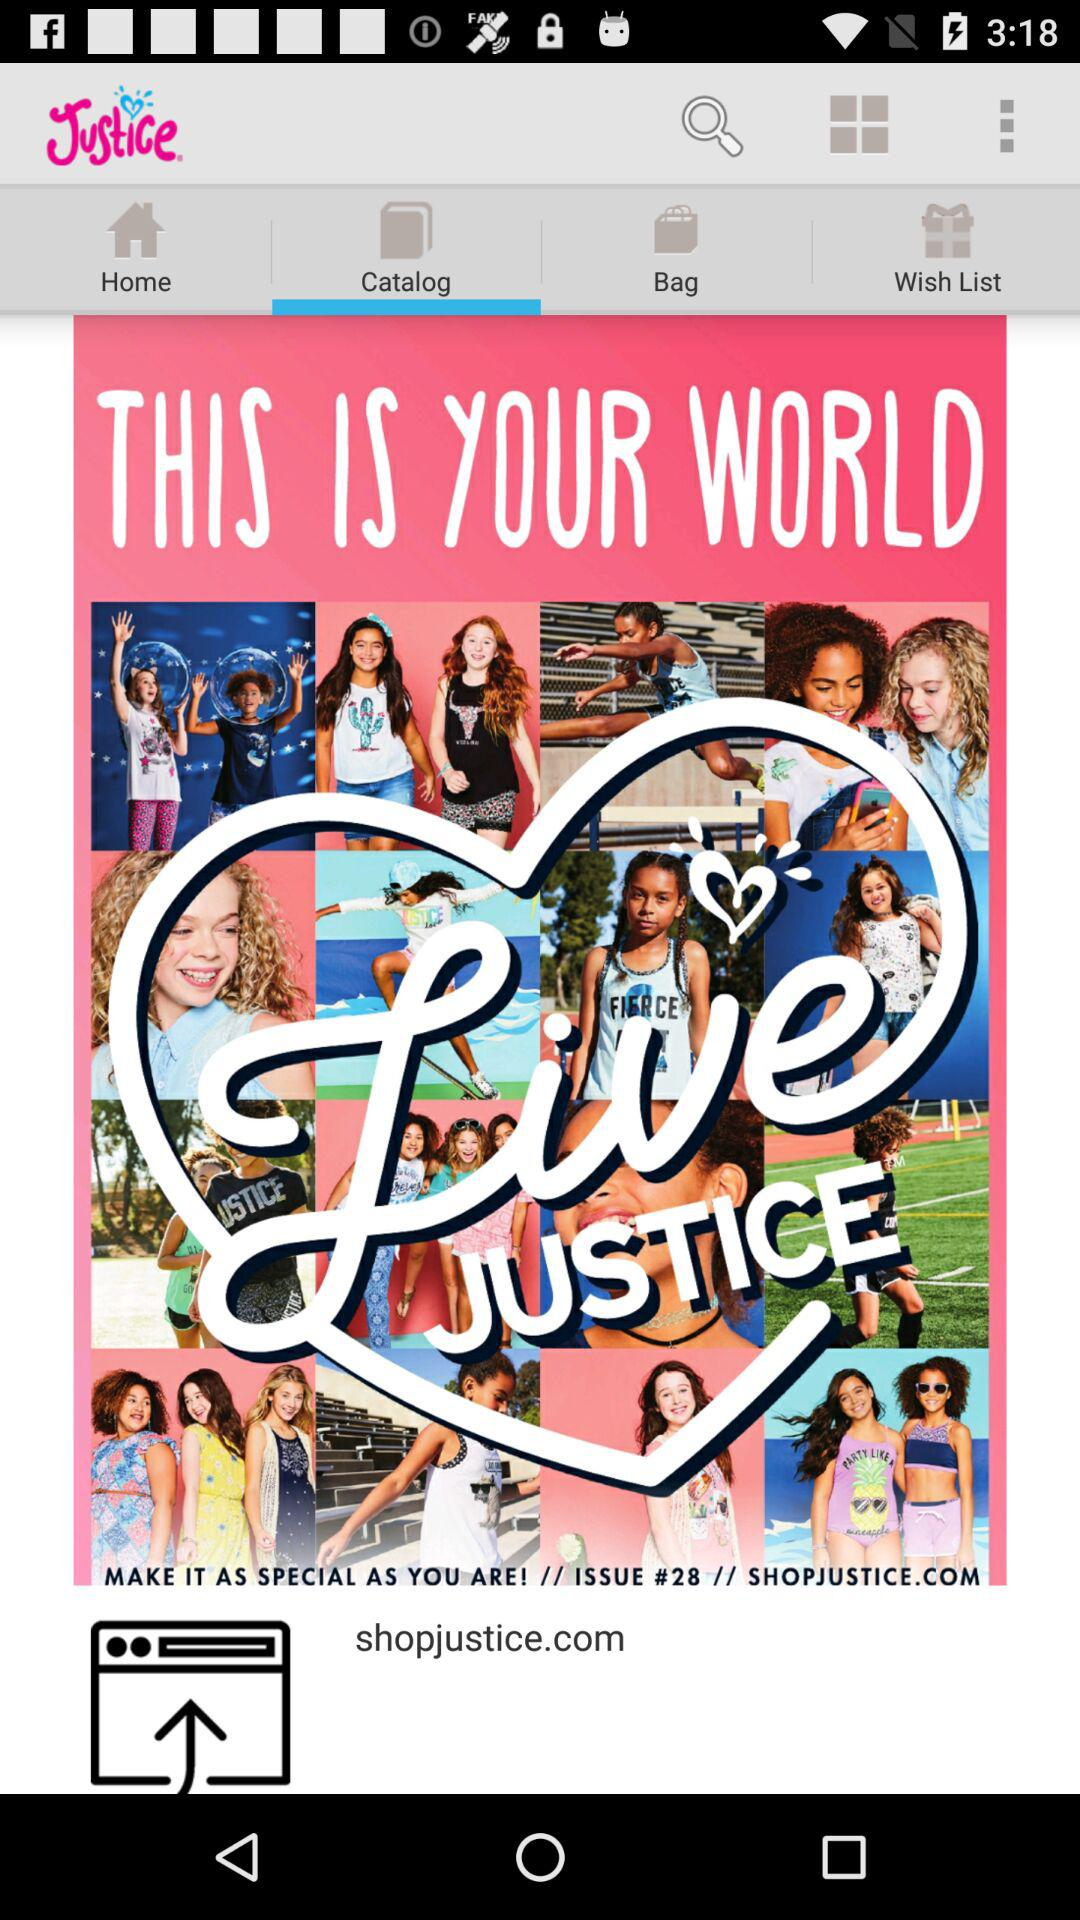What is the email address?
When the provided information is insufficient, respond with <no answer>. <no answer> 